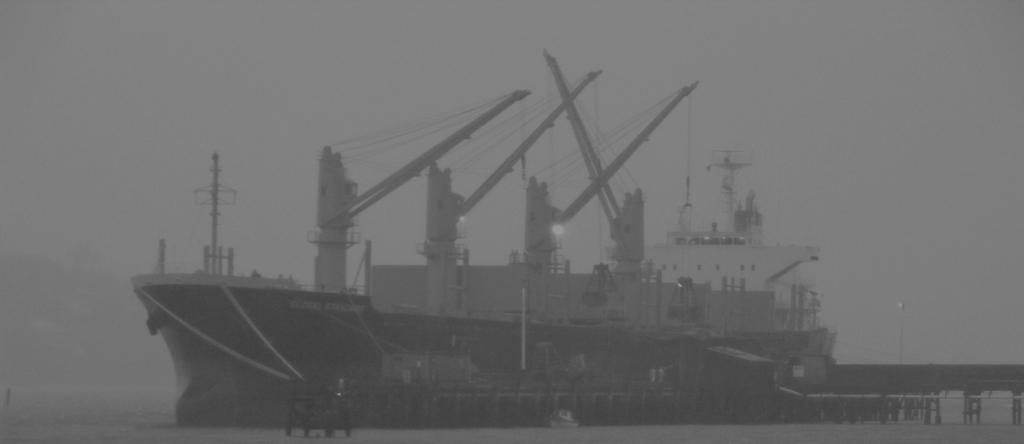What is the main subject of the image? The main subject of the image is a ship. Where is the ship located? The ship is on a sea. What type of leaf can be seen falling into the sea in the image? There is no leaf present in the image; it only features a ship on a sea. 